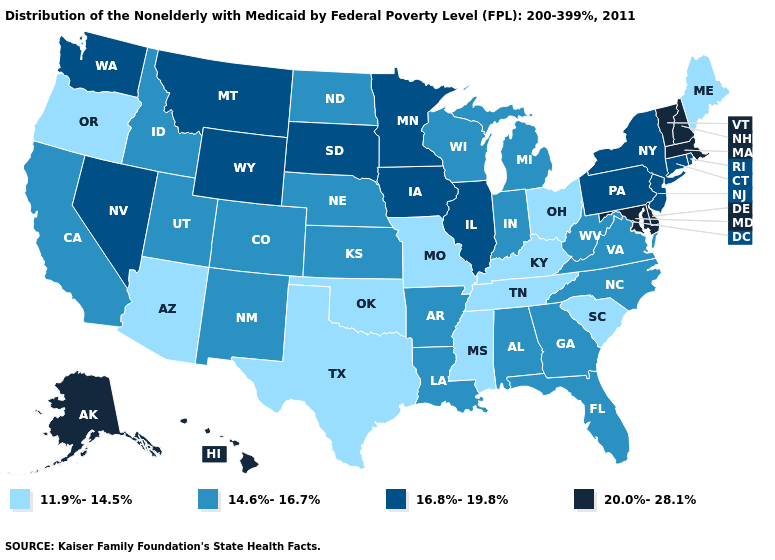How many symbols are there in the legend?
Keep it brief. 4. Does Wisconsin have the lowest value in the MidWest?
Quick response, please. No. What is the value of Mississippi?
Concise answer only. 11.9%-14.5%. Which states have the lowest value in the South?
Concise answer only. Kentucky, Mississippi, Oklahoma, South Carolina, Tennessee, Texas. Among the states that border West Virginia , does Virginia have the highest value?
Short answer required. No. What is the lowest value in the South?
Give a very brief answer. 11.9%-14.5%. What is the highest value in states that border Massachusetts?
Give a very brief answer. 20.0%-28.1%. Does Colorado have a higher value than Mississippi?
Short answer required. Yes. What is the value of Pennsylvania?
Answer briefly. 16.8%-19.8%. Does the map have missing data?
Be succinct. No. Which states hav the highest value in the MidWest?
Answer briefly. Illinois, Iowa, Minnesota, South Dakota. Name the states that have a value in the range 20.0%-28.1%?
Keep it brief. Alaska, Delaware, Hawaii, Maryland, Massachusetts, New Hampshire, Vermont. Does Arizona have the lowest value in the USA?
Concise answer only. Yes. What is the value of Hawaii?
Short answer required. 20.0%-28.1%. Name the states that have a value in the range 14.6%-16.7%?
Concise answer only. Alabama, Arkansas, California, Colorado, Florida, Georgia, Idaho, Indiana, Kansas, Louisiana, Michigan, Nebraska, New Mexico, North Carolina, North Dakota, Utah, Virginia, West Virginia, Wisconsin. 